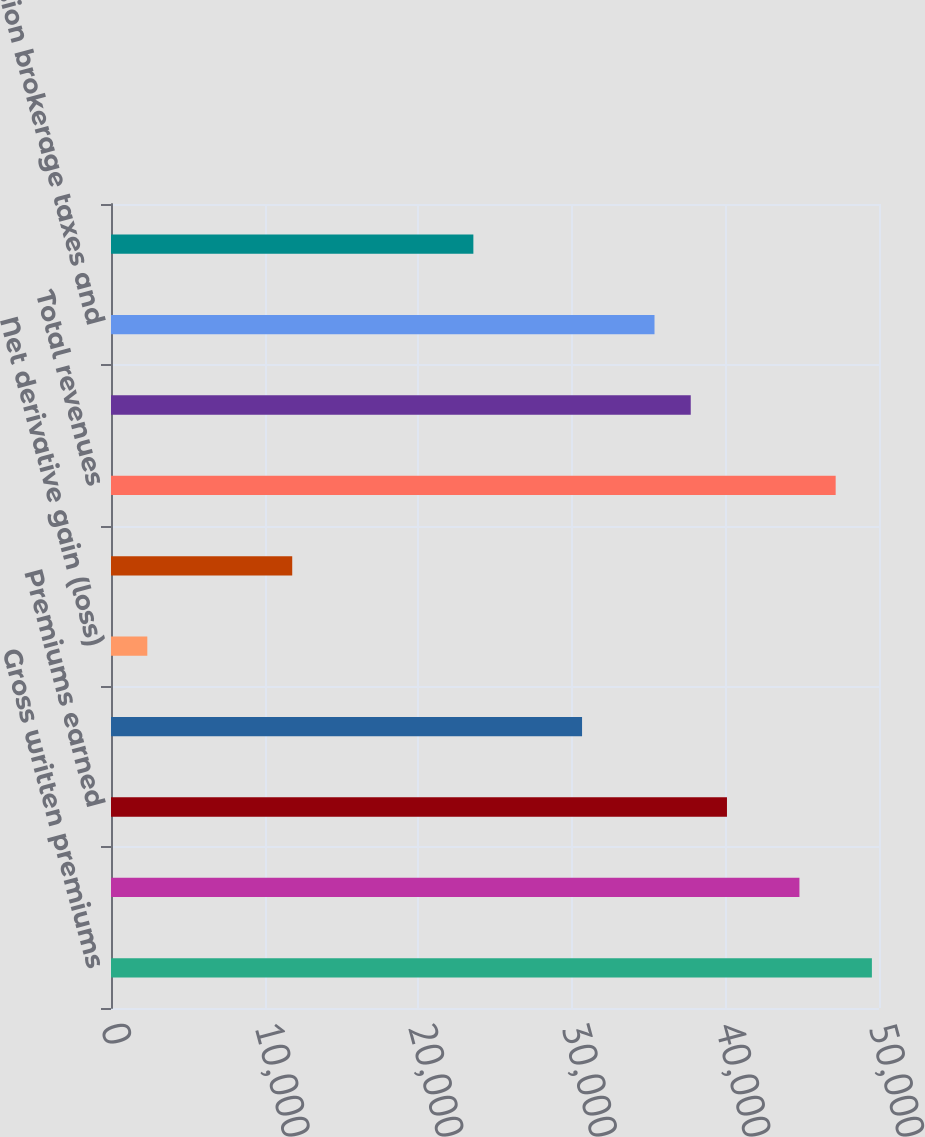Convert chart to OTSL. <chart><loc_0><loc_0><loc_500><loc_500><bar_chart><fcel>Gross written premiums<fcel>Net written premiums<fcel>Premiums earned<fcel>Net investment income<fcel>Net derivative gain (loss)<fcel>Other income (expense)<fcel>Total revenues<fcel>Incurred losses and loss<fcel>Commission brokerage taxes and<fcel>Other underwriting expenses<nl><fcel>49536.9<fcel>44819.7<fcel>40102.3<fcel>30667.8<fcel>2363.95<fcel>11798.5<fcel>47178.3<fcel>37743.7<fcel>35385.1<fcel>23591.8<nl></chart> 